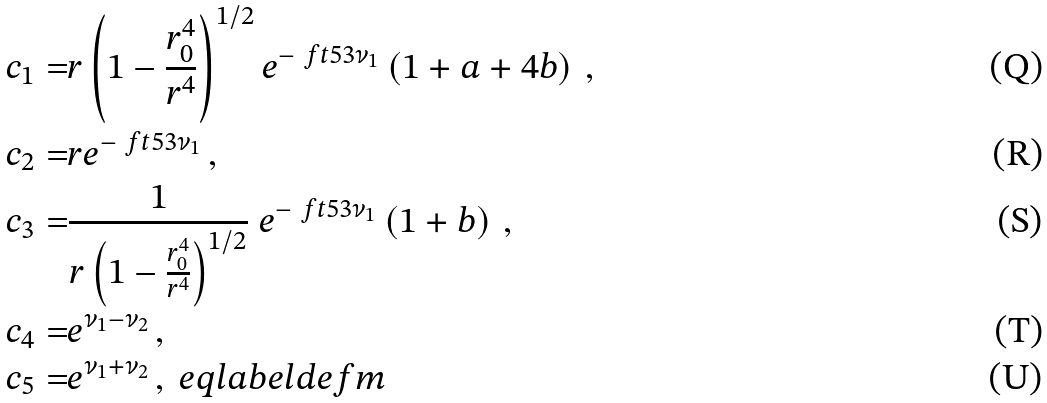<formula> <loc_0><loc_0><loc_500><loc_500>c _ { 1 } = & r \left ( 1 - \frac { r _ { 0 } ^ { 4 } } { r ^ { 4 } } \right ) ^ { 1 / 2 } e ^ { - \ f t 5 3 \nu _ { 1 } } \left ( 1 + a + 4 b \right ) \, , \\ c _ { 2 } = & r e ^ { - \ f t 5 3 \nu _ { 1 } } \, , \\ c _ { 3 } = & \frac { 1 } { r \left ( 1 - \frac { r _ { 0 } ^ { 4 } } { r ^ { 4 } } \right ) ^ { 1 / 2 } } \ e ^ { - \ f t 5 3 \nu _ { 1 } } \left ( 1 + b \right ) \, , \\ c _ { 4 } = & e ^ { \nu _ { 1 } - \nu _ { 2 } } \, , \\ c _ { 5 } = & e ^ { \nu _ { 1 } + \nu _ { 2 } } \, , \ e q l a b e l { d e f m }</formula> 